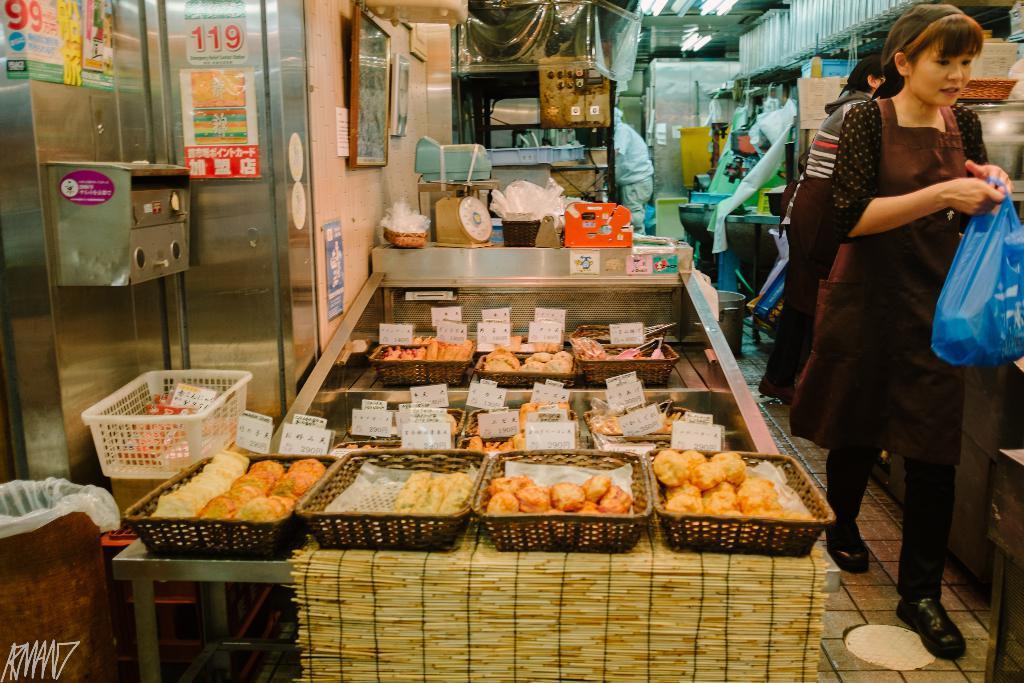In one or two sentences, can you explain what this image depicts? In this image I can see people among them this woman is holding a bag. In the background I can see a wall which has some objects attached to it. I can also see baskets which has food items on it. 